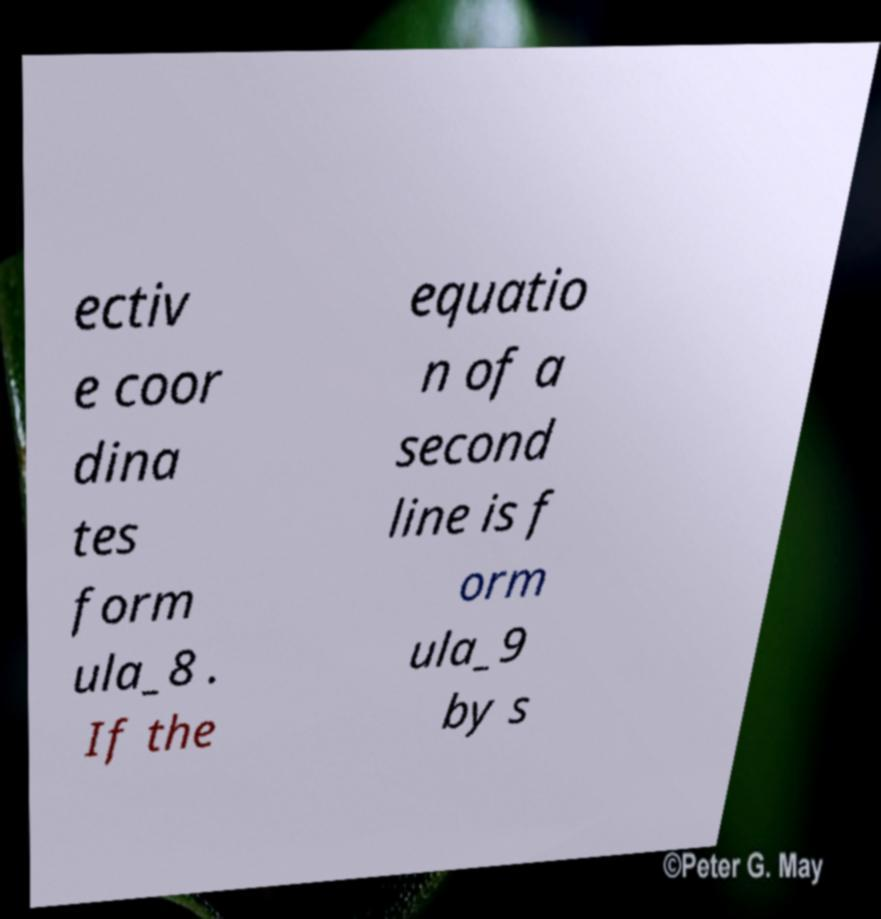Please read and relay the text visible in this image. What does it say? ectiv e coor dina tes form ula_8 . If the equatio n of a second line is f orm ula_9 by s 